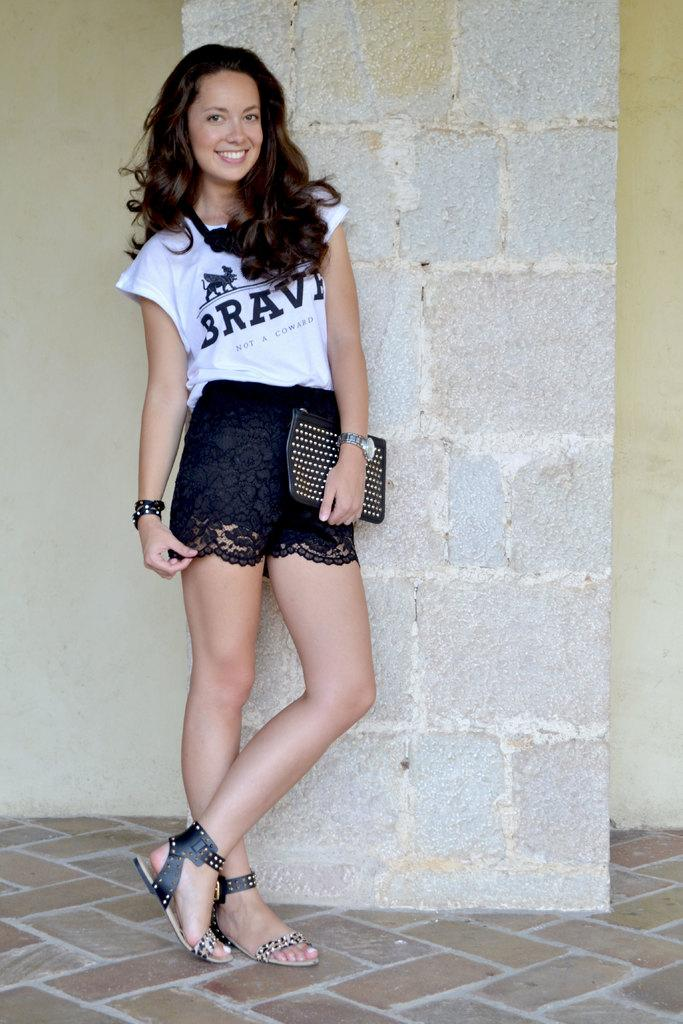Who is the main subject in the image? There is a girl in the image. What is the girl doing in the image? The girl is standing and smiling. What is the girl wearing in the image? She is wearing a white top and a black skirt. What can be seen in the background of the image? There is a wall in the background of the image. How many grandmothers are present in the image? There is no grandmother present in the image; it features a girl. What type of bird can be seen flying near the girl in the image? There is no bird present in the image; it only features the girl and a wall in the background. 